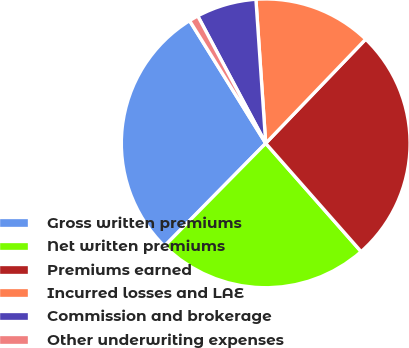<chart> <loc_0><loc_0><loc_500><loc_500><pie_chart><fcel>Gross written premiums<fcel>Net written premiums<fcel>Premiums earned<fcel>Incurred losses and LAE<fcel>Commission and brokerage<fcel>Other underwriting expenses<nl><fcel>28.78%<fcel>23.88%<fcel>26.33%<fcel>13.26%<fcel>6.72%<fcel>1.04%<nl></chart> 